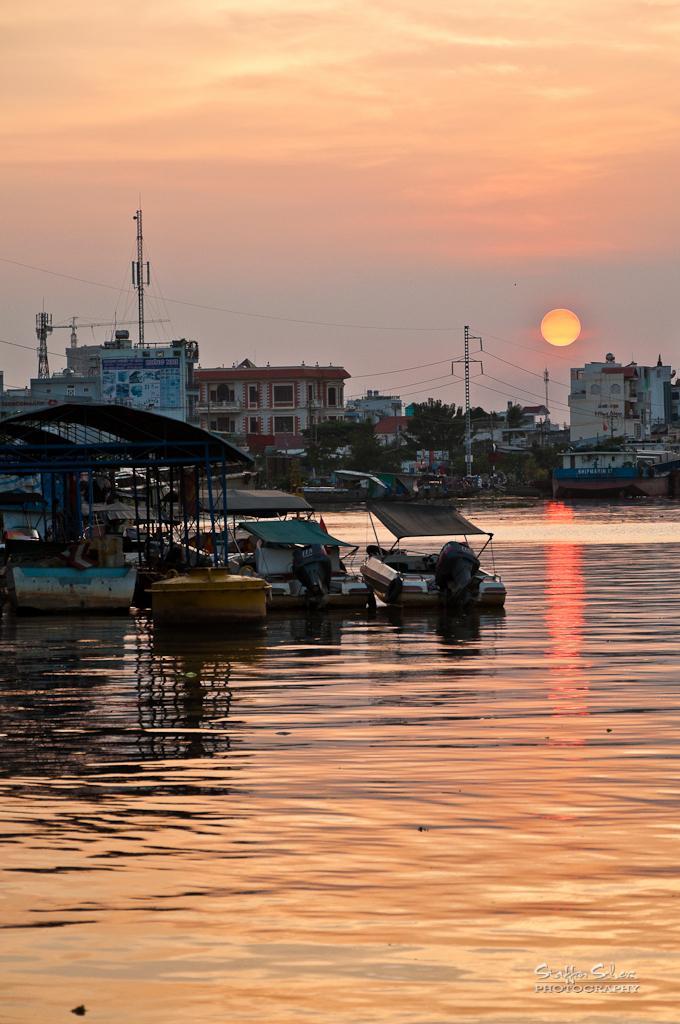Can you describe this image briefly? In this image there are buildings, poles, crane tower, trees, boards, water, boats, cloudy sky, sun and things. At the bottom right side of the image there is a watermark. 